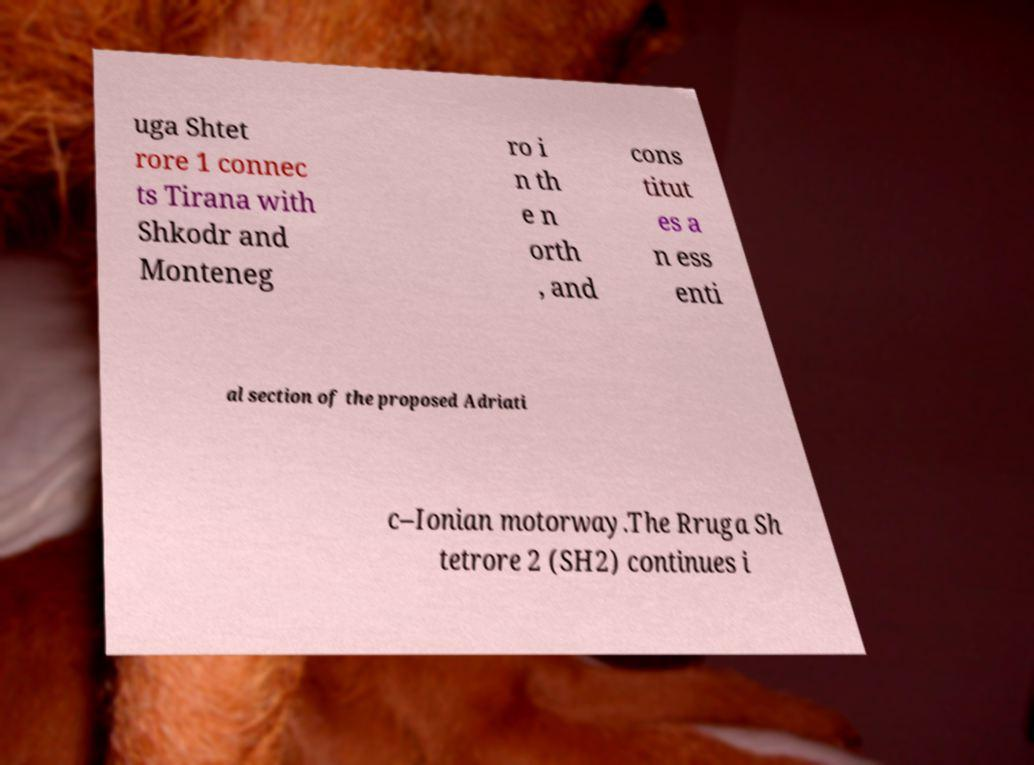What messages or text are displayed in this image? I need them in a readable, typed format. uga Shtet rore 1 connec ts Tirana with Shkodr and Monteneg ro i n th e n orth , and cons titut es a n ess enti al section of the proposed Adriati c–Ionian motorway.The Rruga Sh tetrore 2 (SH2) continues i 